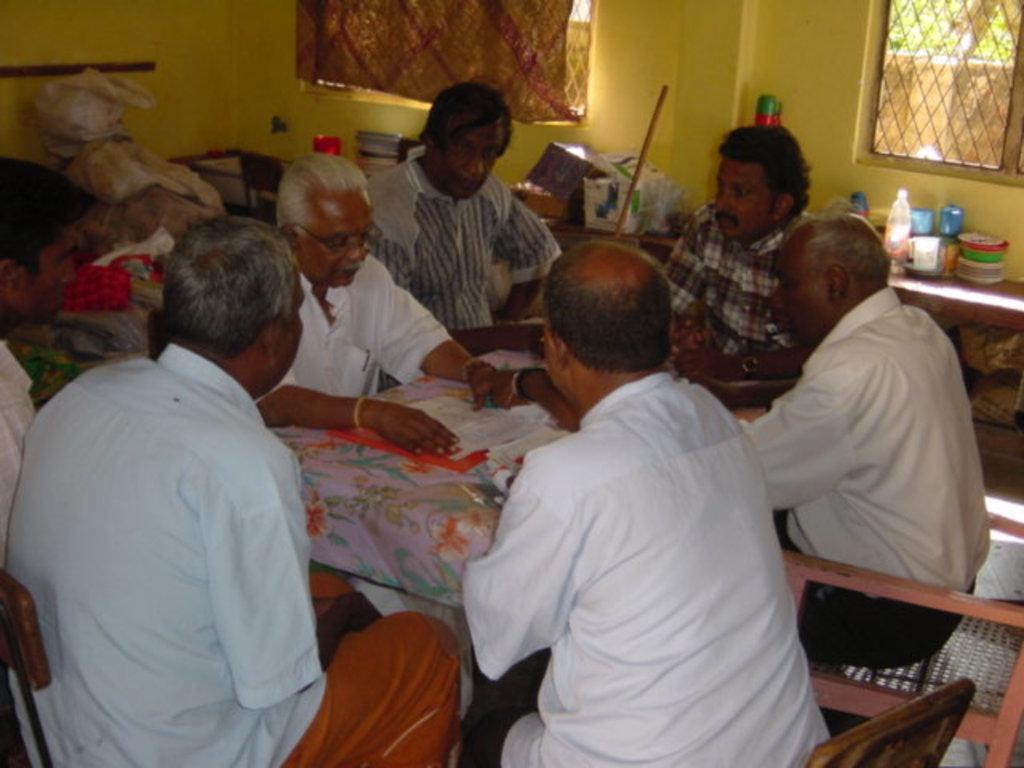How would you summarize this image in a sentence or two? In the image there is a man who is sitting in the chair and at right side of him there are 3 persons sitting in the chair and another 2 persons sitting in the chair and there is a table with some papers and at the back ground there is a curtain , window , pouch or a bag , books , stick, bottle , cup, plates in the table and a window. 